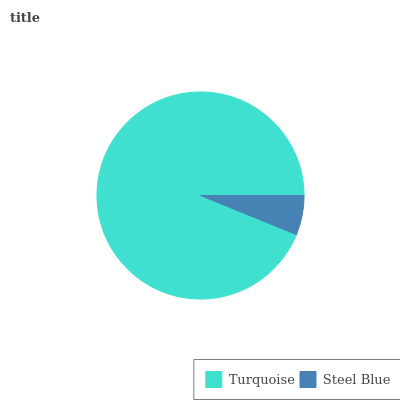Is Steel Blue the minimum?
Answer yes or no. Yes. Is Turquoise the maximum?
Answer yes or no. Yes. Is Steel Blue the maximum?
Answer yes or no. No. Is Turquoise greater than Steel Blue?
Answer yes or no. Yes. Is Steel Blue less than Turquoise?
Answer yes or no. Yes. Is Steel Blue greater than Turquoise?
Answer yes or no. No. Is Turquoise less than Steel Blue?
Answer yes or no. No. Is Turquoise the high median?
Answer yes or no. Yes. Is Steel Blue the low median?
Answer yes or no. Yes. Is Steel Blue the high median?
Answer yes or no. No. Is Turquoise the low median?
Answer yes or no. No. 